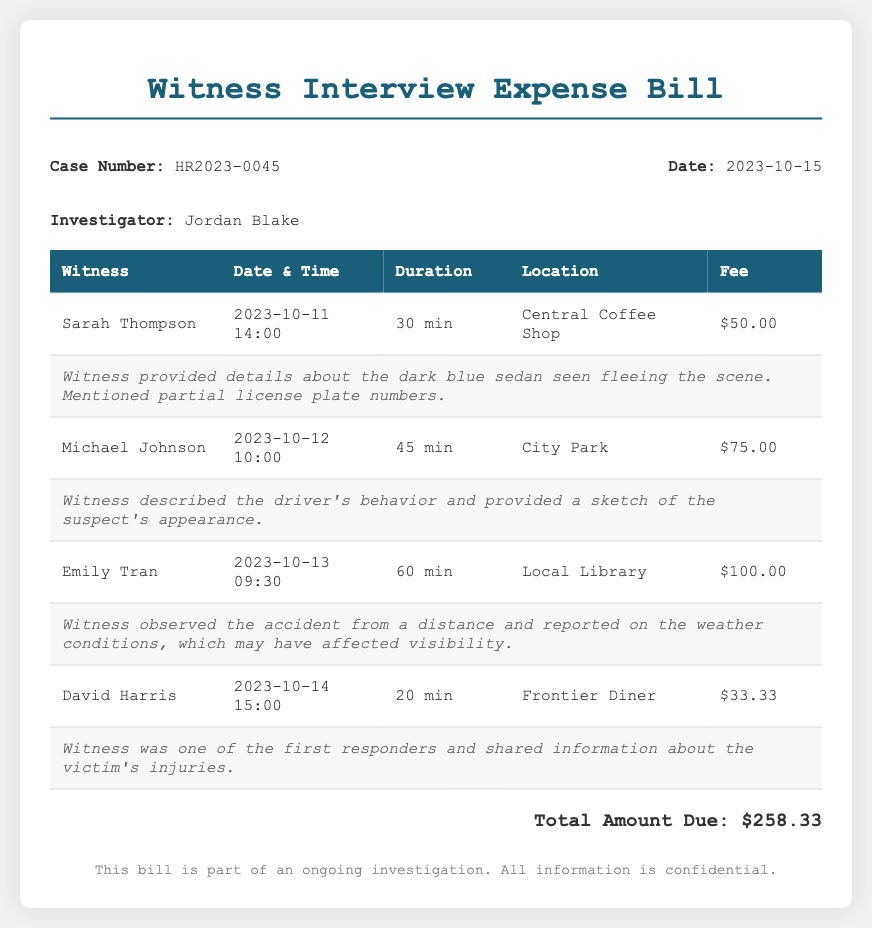What is the case number? The case number is mentioned in the document under the case info section.
Answer: HR2023-0045 What date was the bill issued? The date is specified in the case info section of the document.
Answer: 2023-10-15 Who is the investigator? The investigator's name is provided in the document.
Answer: Jordan Blake How much did Emily Tran's interview cost? The fee for Emily Tran's interview is listed in the table.
Answer: $100.00 What was the total amount due? The total amount due is provided at the bottom of the document.
Answer: $258.33 Which witness provided a sketch of the suspect's appearance? The witness who provided a sketch is detailed in the summary for Michael Johnson.
Answer: Michael Johnson How long was the interview with David Harris? The duration of the interview with David Harris is noted in the table.
Answer: 20 min What location did Sarah Thompson's interview take place? The location of Sarah Thompson's interview is mentioned in the table.
Answer: Central Coffee Shop What was one detail mentioned by Sarah Thompson? The summary for Sarah Thompson provides key details shared during the interview.
Answer: dark blue sedan 